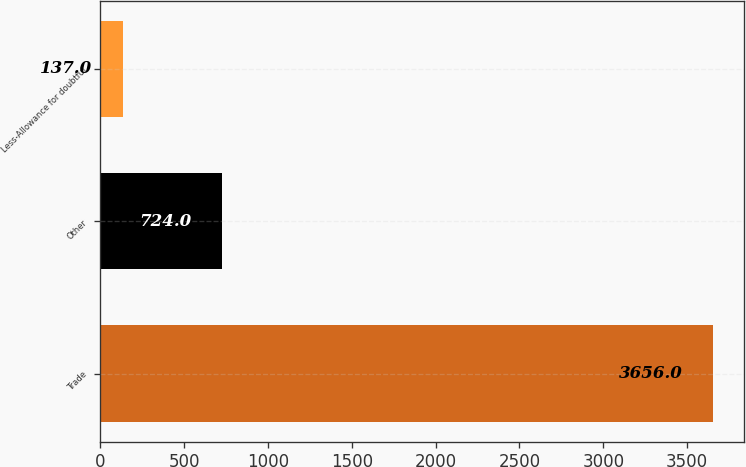<chart> <loc_0><loc_0><loc_500><loc_500><bar_chart><fcel>Trade<fcel>Other<fcel>Less-Allowance for doubtful<nl><fcel>3656<fcel>724<fcel>137<nl></chart> 